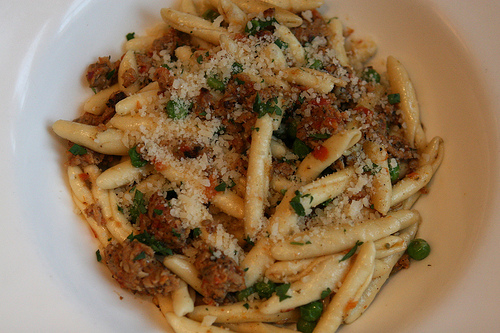<image>
Can you confirm if the cheese is behind the pasta? No. The cheese is not behind the pasta. From this viewpoint, the cheese appears to be positioned elsewhere in the scene. 